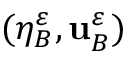Convert formula to latex. <formula><loc_0><loc_0><loc_500><loc_500>( \eta _ { B } ^ { \varepsilon } , u _ { B } ^ { \varepsilon } )</formula> 